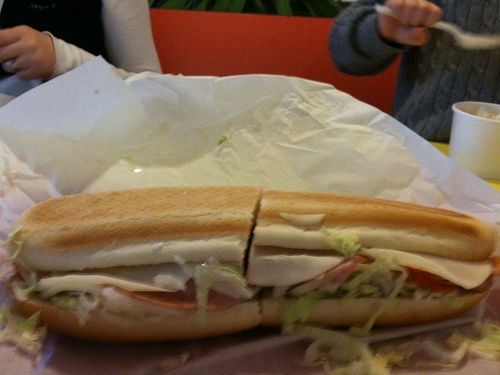Describe the objects in this image and their specific colors. I can see sandwich in gray, maroon, tan, and olive tones, people in gray, black, and maroon tones, people in gray, black, and darkgray tones, cup in gray, darkgray, and tan tones, and spoon in gray tones in this image. 